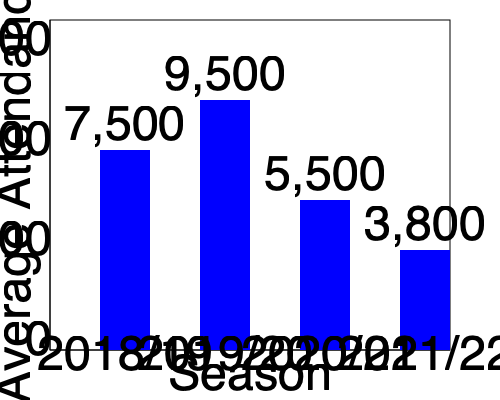Based on the bar chart showing average attendance at Peterborough United home games across different seasons, what was the percentage decrease in average attendance from the 2019/20 season to the 2021/22 season? To calculate the percentage decrease in average attendance from the 2019/20 season to the 2021/22 season, we'll follow these steps:

1. Identify the average attendance for the 2019/20 season: 9,500
2. Identify the average attendance for the 2021/22 season: 3,800
3. Calculate the decrease in attendance:
   $9,500 - 3,800 = 5,700$
4. Calculate the percentage decrease:
   $\text{Percentage decrease} = \frac{\text{Decrease}}{\text{Original Value}} \times 100\%$
   $= \frac{5,700}{9,500} \times 100\%$
   $= 0.6 \times 100\%$
   $= 60\%$

Therefore, the percentage decrease in average attendance from the 2019/20 season to the 2021/22 season was 60%.
Answer: 60% 